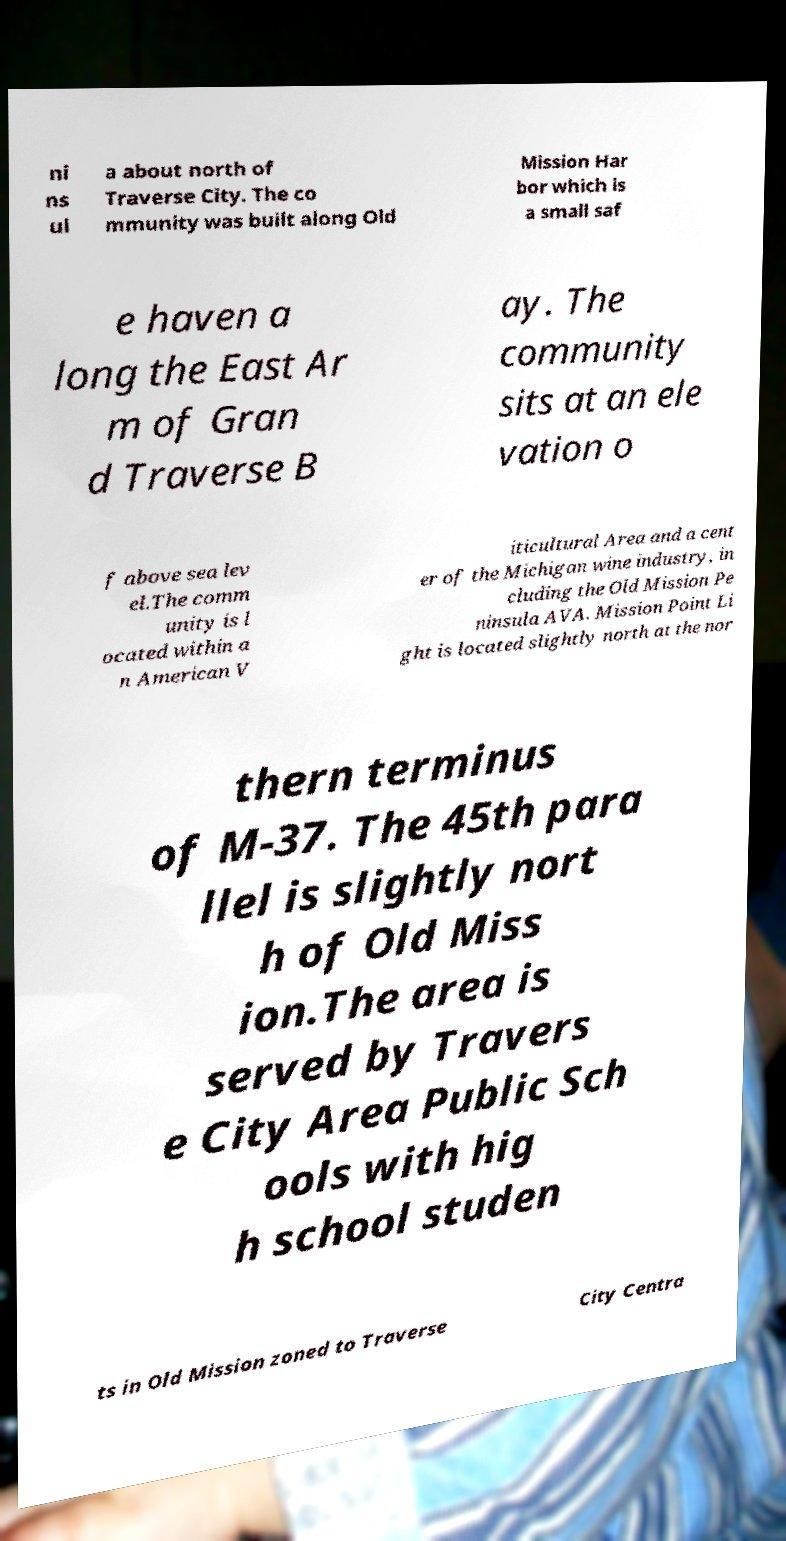I need the written content from this picture converted into text. Can you do that? ni ns ul a about north of Traverse City. The co mmunity was built along Old Mission Har bor which is a small saf e haven a long the East Ar m of Gran d Traverse B ay. The community sits at an ele vation o f above sea lev el.The comm unity is l ocated within a n American V iticultural Area and a cent er of the Michigan wine industry, in cluding the Old Mission Pe ninsula AVA. Mission Point Li ght is located slightly north at the nor thern terminus of M-37. The 45th para llel is slightly nort h of Old Miss ion.The area is served by Travers e City Area Public Sch ools with hig h school studen ts in Old Mission zoned to Traverse City Centra 